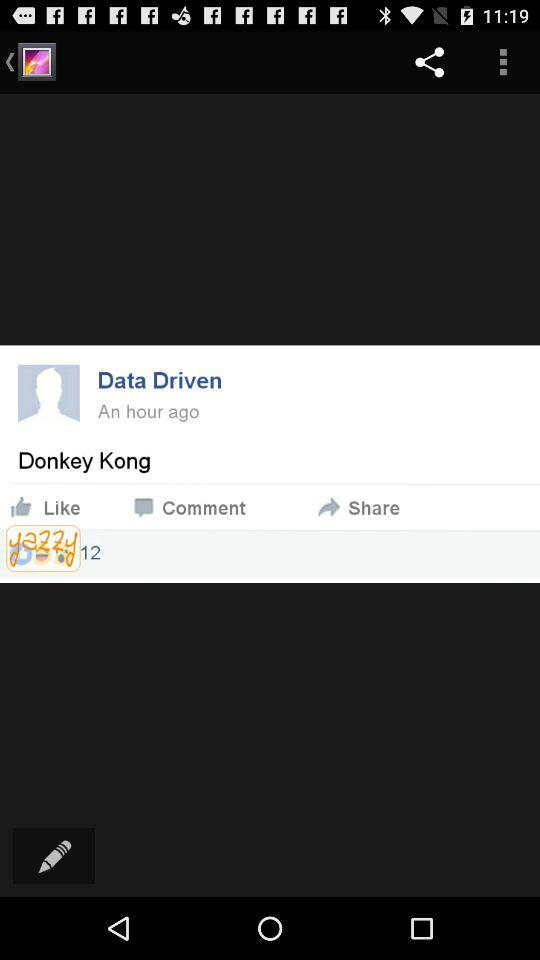How many total reactions are there on the post? There are a total of 12 reactions on the post. 